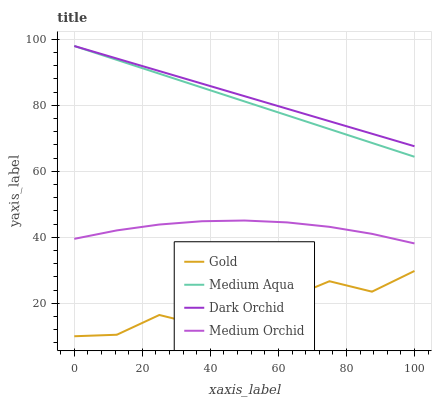Does Medium Aqua have the minimum area under the curve?
Answer yes or no. No. Does Medium Aqua have the maximum area under the curve?
Answer yes or no. No. Is Medium Aqua the smoothest?
Answer yes or no. No. Is Medium Aqua the roughest?
Answer yes or no. No. Does Medium Aqua have the lowest value?
Answer yes or no. No. Does Gold have the highest value?
Answer yes or no. No. Is Medium Orchid less than Medium Aqua?
Answer yes or no. Yes. Is Dark Orchid greater than Gold?
Answer yes or no. Yes. Does Medium Orchid intersect Medium Aqua?
Answer yes or no. No. 